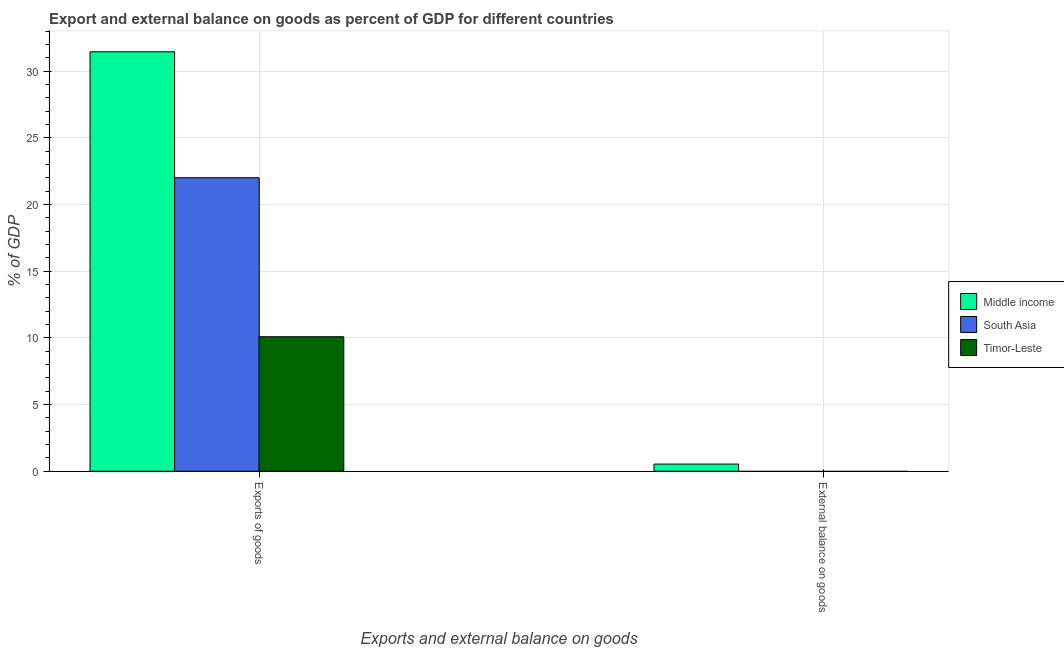Are the number of bars per tick equal to the number of legend labels?
Your response must be concise. No. Are the number of bars on each tick of the X-axis equal?
Your response must be concise. No. How many bars are there on the 1st tick from the right?
Keep it short and to the point. 1. What is the label of the 2nd group of bars from the left?
Offer a very short reply. External balance on goods. What is the export of goods as percentage of gdp in South Asia?
Offer a terse response. 22.01. Across all countries, what is the maximum external balance on goods as percentage of gdp?
Give a very brief answer. 0.54. In which country was the export of goods as percentage of gdp maximum?
Your answer should be very brief. Middle income. What is the total external balance on goods as percentage of gdp in the graph?
Ensure brevity in your answer.  0.54. What is the difference between the export of goods as percentage of gdp in Timor-Leste and that in Middle income?
Your answer should be compact. -21.37. What is the difference between the external balance on goods as percentage of gdp in South Asia and the export of goods as percentage of gdp in Middle income?
Your response must be concise. -31.45. What is the average external balance on goods as percentage of gdp per country?
Offer a terse response. 0.18. What is the difference between the export of goods as percentage of gdp and external balance on goods as percentage of gdp in Middle income?
Make the answer very short. 30.92. In how many countries, is the export of goods as percentage of gdp greater than 17 %?
Provide a short and direct response. 2. What is the ratio of the export of goods as percentage of gdp in Timor-Leste to that in Middle income?
Ensure brevity in your answer.  0.32. Are all the bars in the graph horizontal?
Your answer should be very brief. No. What is the difference between two consecutive major ticks on the Y-axis?
Your answer should be compact. 5. Does the graph contain any zero values?
Make the answer very short. Yes. What is the title of the graph?
Your answer should be compact. Export and external balance on goods as percent of GDP for different countries. Does "Malawi" appear as one of the legend labels in the graph?
Give a very brief answer. No. What is the label or title of the X-axis?
Ensure brevity in your answer.  Exports and external balance on goods. What is the label or title of the Y-axis?
Offer a very short reply. % of GDP. What is the % of GDP of Middle income in Exports of goods?
Ensure brevity in your answer.  31.45. What is the % of GDP in South Asia in Exports of goods?
Give a very brief answer. 22.01. What is the % of GDP of Timor-Leste in Exports of goods?
Keep it short and to the point. 10.09. What is the % of GDP in Middle income in External balance on goods?
Your answer should be compact. 0.54. What is the % of GDP of Timor-Leste in External balance on goods?
Keep it short and to the point. 0. Across all Exports and external balance on goods, what is the maximum % of GDP of Middle income?
Your answer should be compact. 31.45. Across all Exports and external balance on goods, what is the maximum % of GDP of South Asia?
Provide a short and direct response. 22.01. Across all Exports and external balance on goods, what is the maximum % of GDP of Timor-Leste?
Your answer should be very brief. 10.09. Across all Exports and external balance on goods, what is the minimum % of GDP of Middle income?
Give a very brief answer. 0.54. Across all Exports and external balance on goods, what is the minimum % of GDP in South Asia?
Your response must be concise. 0. Across all Exports and external balance on goods, what is the minimum % of GDP of Timor-Leste?
Your answer should be very brief. 0. What is the total % of GDP in Middle income in the graph?
Make the answer very short. 31.99. What is the total % of GDP in South Asia in the graph?
Your answer should be very brief. 22.01. What is the total % of GDP of Timor-Leste in the graph?
Ensure brevity in your answer.  10.09. What is the difference between the % of GDP in Middle income in Exports of goods and that in External balance on goods?
Provide a short and direct response. 30.92. What is the average % of GDP in Middle income per Exports and external balance on goods?
Keep it short and to the point. 16. What is the average % of GDP in South Asia per Exports and external balance on goods?
Offer a terse response. 11.01. What is the average % of GDP in Timor-Leste per Exports and external balance on goods?
Make the answer very short. 5.04. What is the difference between the % of GDP in Middle income and % of GDP in South Asia in Exports of goods?
Your answer should be compact. 9.44. What is the difference between the % of GDP in Middle income and % of GDP in Timor-Leste in Exports of goods?
Your answer should be very brief. 21.37. What is the difference between the % of GDP of South Asia and % of GDP of Timor-Leste in Exports of goods?
Your response must be concise. 11.92. What is the ratio of the % of GDP in Middle income in Exports of goods to that in External balance on goods?
Provide a short and direct response. 58.57. What is the difference between the highest and the second highest % of GDP of Middle income?
Offer a terse response. 30.92. What is the difference between the highest and the lowest % of GDP of Middle income?
Keep it short and to the point. 30.92. What is the difference between the highest and the lowest % of GDP in South Asia?
Offer a terse response. 22.01. What is the difference between the highest and the lowest % of GDP in Timor-Leste?
Keep it short and to the point. 10.09. 